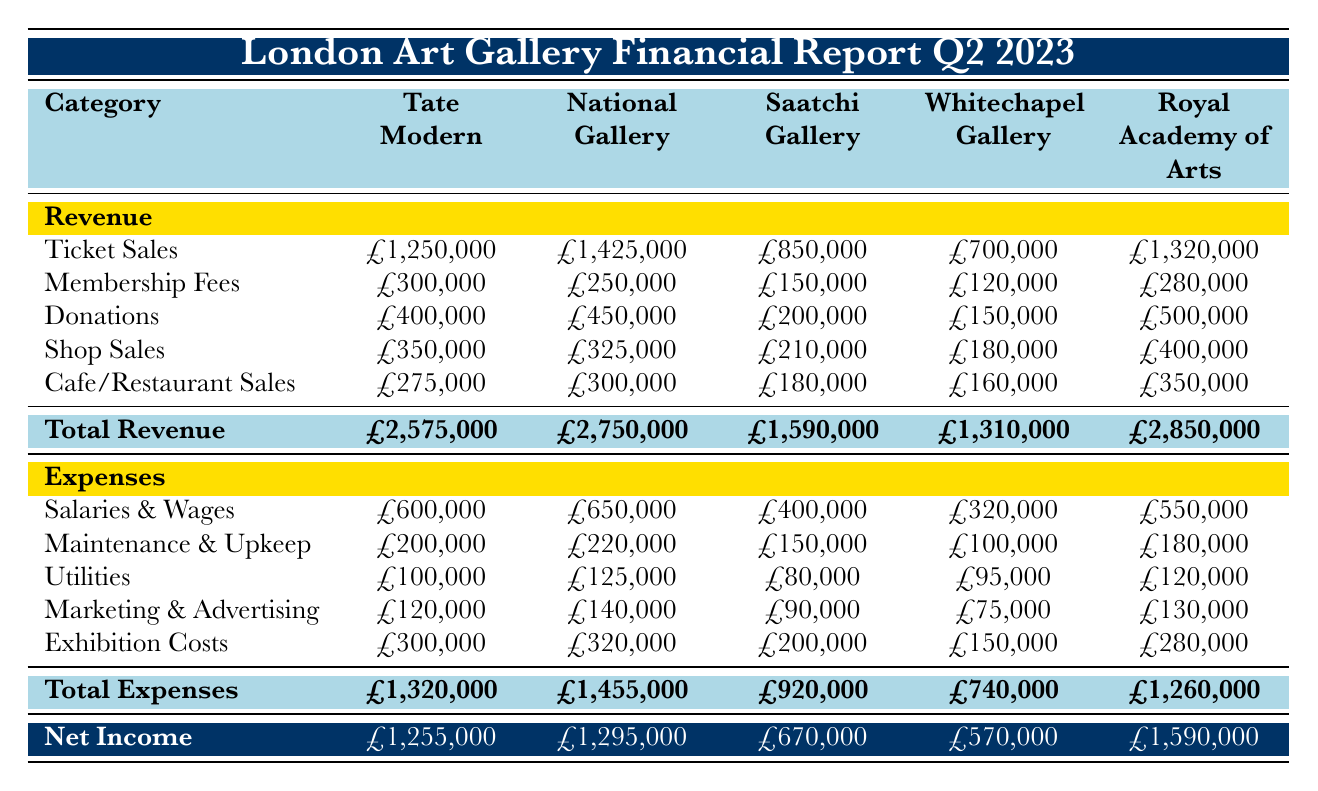What was the highest revenue source for the National Gallery? By examining the revenue section for the National Gallery, we can compare the values for ticket sales, membership fees, donations, shop sales, and cafe/restaurant sales. The highest value among them is £1,425,000 from ticket sales.
Answer: Ticket Sales What is the total revenue for the Tate Modern? To find the total revenue for Tate Modern, we sum all its revenue sources: ticket sales (£1,250,000) + membership fees (£300,000) + donations (£400,000) + shop sales (£350,000) + cafe/restaurant sales (£275,000). Adding these gives us £2,575,000.
Answer: £2,575,000 Did the Royal Academy of Arts spend more on salaries and wages, or on exhibition costs? The Royal Academy of Arts spent £550,000 on salaries and wages and £280,000 on exhibition costs. Since £550,000 is greater than £280,000, it indicates that they did spend more on salaries and wages.
Answer: Yes What is the difference in total expenses between the Saatchi Gallery and the Whitechapel Gallery? To find the difference, we subtract the total expenses of Whitechapel Gallery (£740,000) from those of Saatchi Gallery (£920,000). The calculation is £920,000 - £740,000 = £180,000.
Answer: £180,000 What percentage of the total revenue did donations represent for the Royal Academy of Arts? First, we identify the total revenue for the Royal Academy of Arts (£2,850,000) and the donation amount (£500,000). To find the percentage, we use the formula (donations/total revenue) * 100 = (£500,000 / £2,850,000) * 100. This gives approximately 17.54%.
Answer: Approximately 17.54% 